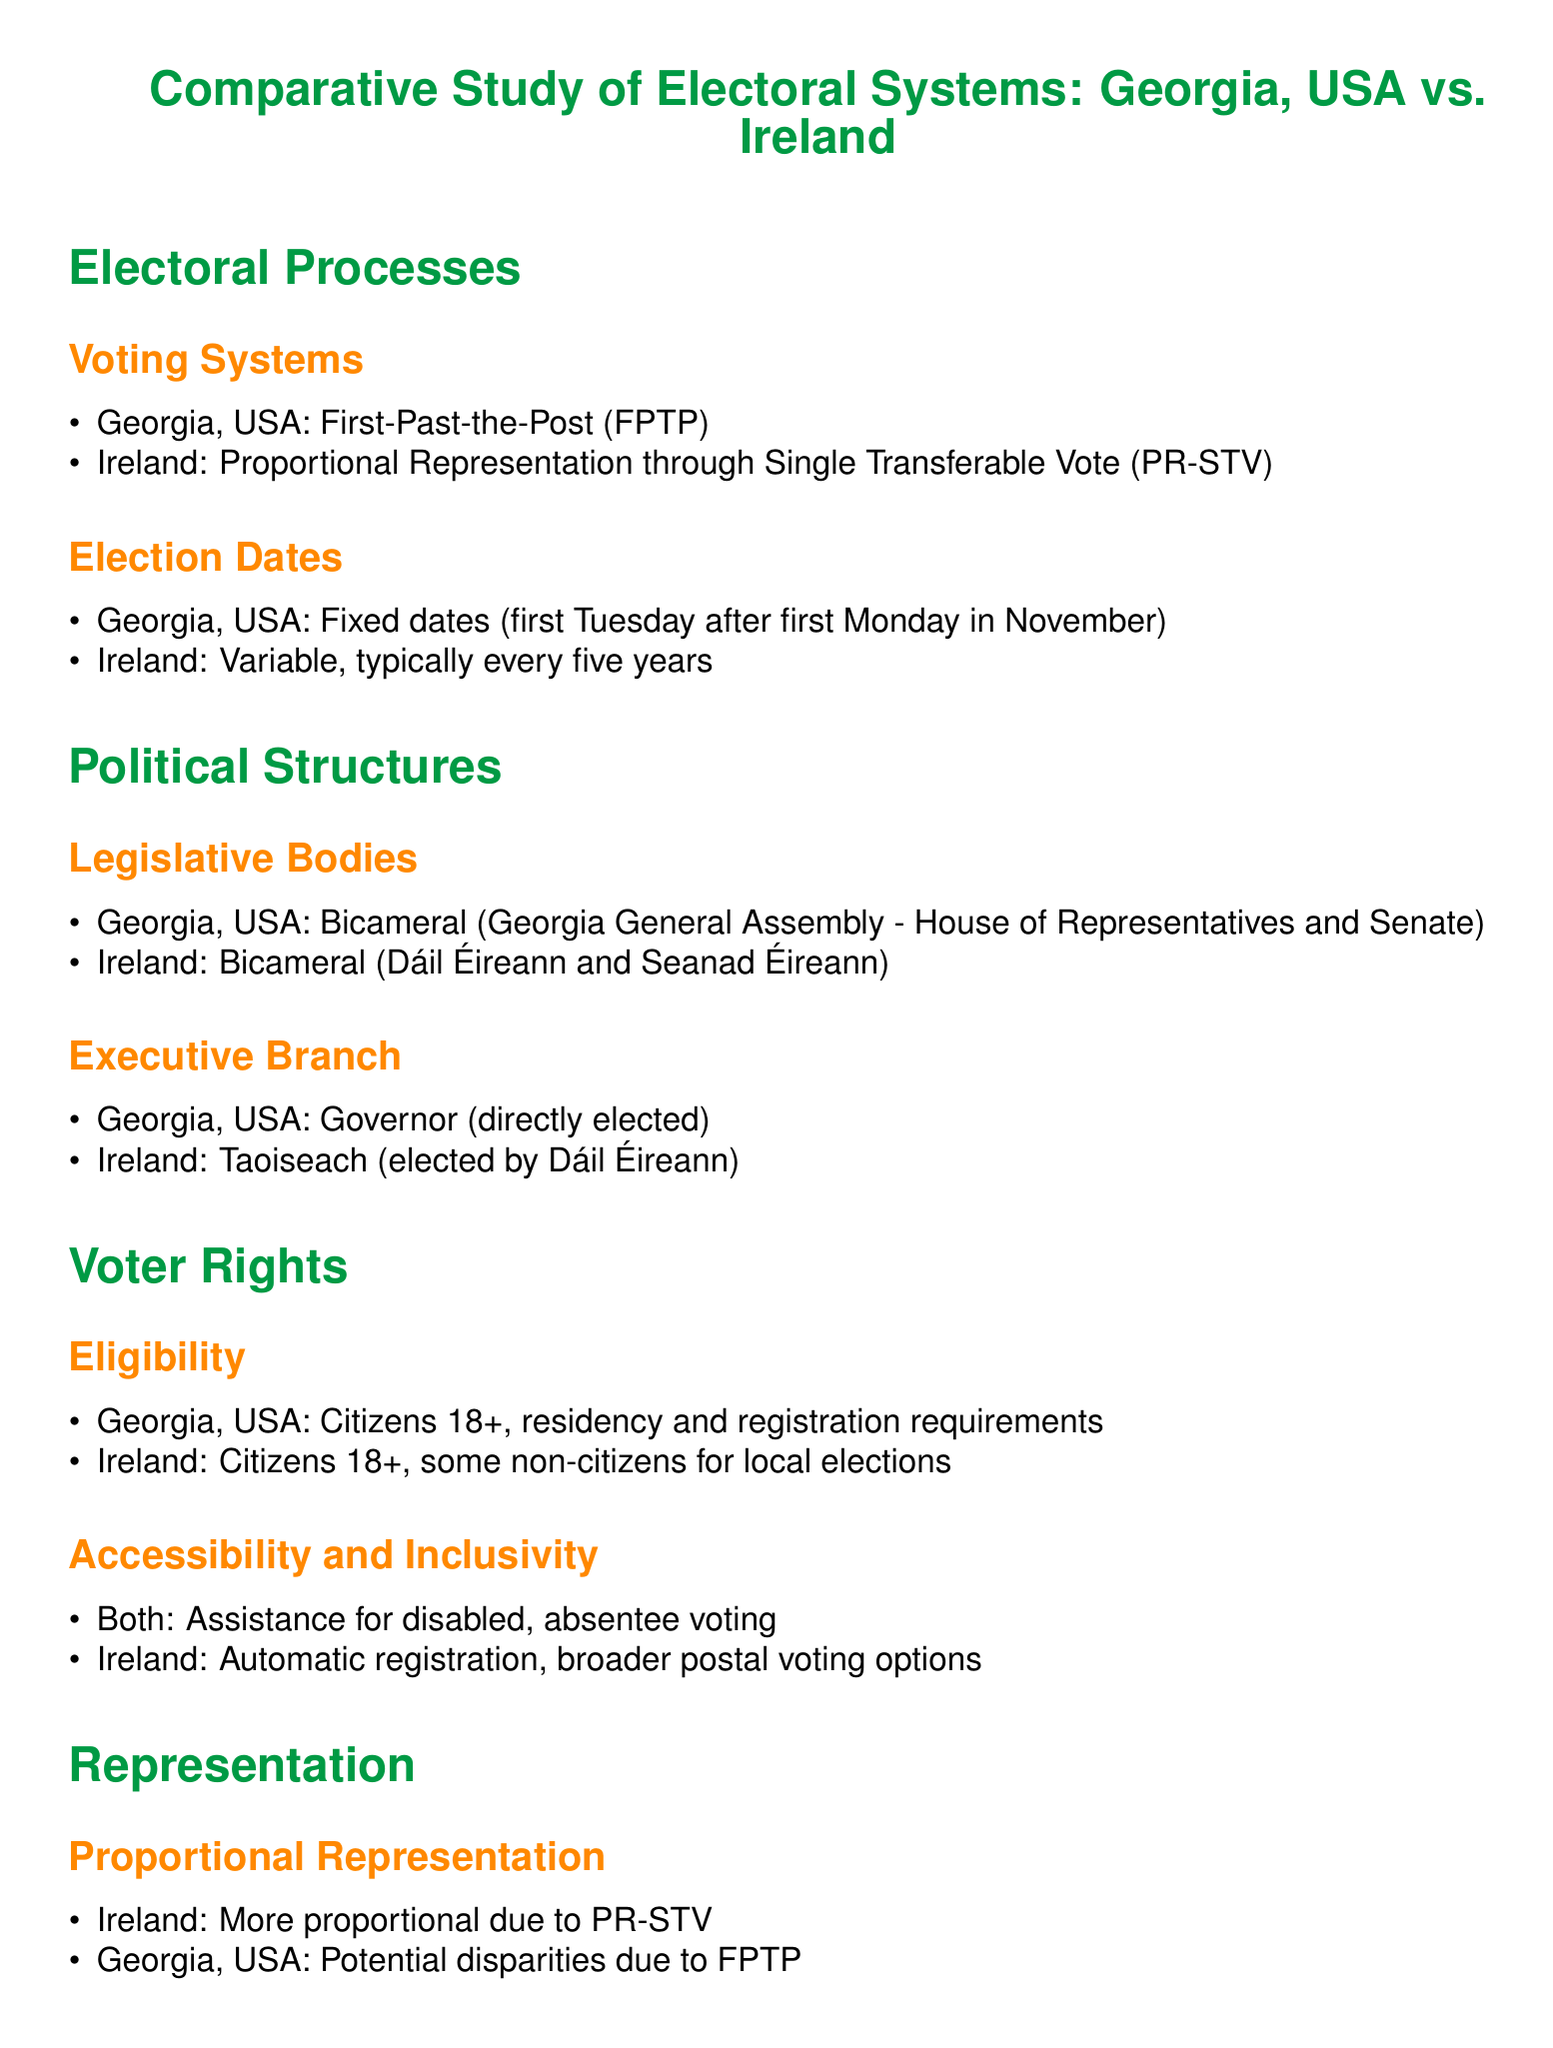What voting system is used in Georgia, USA? The document states that Georgia, USA uses the First-Past-the-Post (FPTP) voting system.
Answer: First-Past-the-Post What voting system is used in Ireland? The document mentions that Ireland employs Proportional Representation through Single Transferable Vote (PR-STV).
Answer: Proportional Representation through Single Transferable Vote What is the election date for Georgia, USA? According to the document, election dates in Georgia, USA are fixed for the first Tuesday after the first Monday in November.
Answer: First Tuesday after first Monday in November What is the term length for elections in Ireland? The document indicates that elections in Ireland are typically every five years, which is a fixed term.
Answer: Every five years Who is the head of the executive branch in Georgia, USA? The document identifies the Governor as the head of the executive branch in Georgia, USA.
Answer: Governor How is the Taoiseach elected in Ireland? The document states that the Taoiseach is elected by Dáil Éireann.
Answer: Elected by Dáil Éireann What is the voter eligibility age in both Georgia, USA and Ireland? The document states that the voter eligibility age is 18 years in both jurisdictions.
Answer: 18 years What is a key difference between minority representation in Georgia, USA and Ireland? The document highlights that Georgia, USA uses minority-majority districts, while Ireland achieves natural diversity through its proportional system.
Answer: Minority-majority districts vs. natural diversity In terms of accessibility, what option does Ireland offer that Georgia, USA does not? The document points out that Ireland offers broader postal voting options for voters.
Answer: Broader postal voting options What is emphasized about voter rights in terms of assistance? The document notes that both Georgia, USA and Ireland provide assistance for disabled voters and absentee voting options.
Answer: Assistance for disabled, absentee voting 